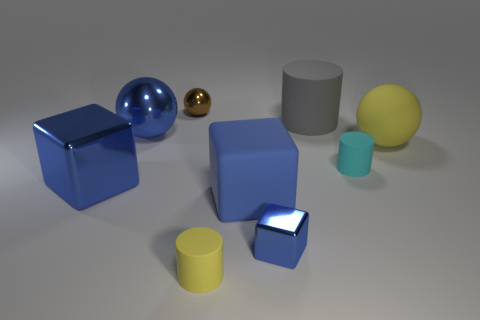Add 1 blue objects. How many objects exist? 10 Subtract all cylinders. How many objects are left? 6 Subtract all big blue metal balls. Subtract all cyan rubber cylinders. How many objects are left? 7 Add 8 big metal objects. How many big metal objects are left? 10 Add 8 green spheres. How many green spheres exist? 8 Subtract 1 cyan cylinders. How many objects are left? 8 